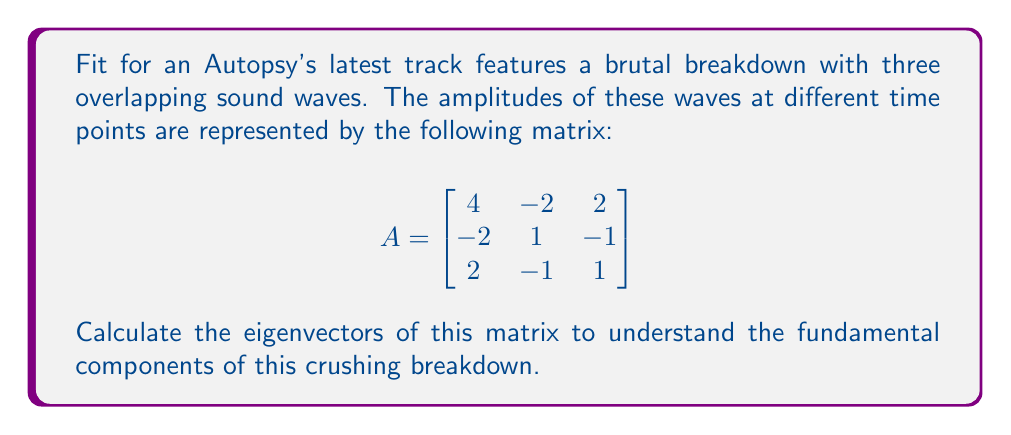Help me with this question. To find the eigenvectors, we follow these steps:

1) First, we need to find the eigenvalues by solving the characteristic equation:
   $$det(A - \lambda I) = 0$$

2) Expanding this:
   $$\begin{vmatrix}
   4-\lambda & -2 & 2 \\
   -2 & 1-\lambda & -1 \\
   2 & -1 & 1-\lambda
   \end{vmatrix} = 0$$

3) This gives us:
   $$(4-\lambda)((1-\lambda)^2 - 1) + 2(2(1-\lambda) + 2) - 2(-2(1-\lambda) - 1) = 0$$
   $$(4-\lambda)(1-2\lambda+\lambda^2 - 1) + 4(1-\lambda) + 4 + 4(1-\lambda) + 2 = 0$$
   $$-\lambda(4-\lambda)(\lambda-2) + 8-4\lambda + 4 + 4-4\lambda + 2 = 0$$
   $$-\lambda^3+2\lambda^2+4\lambda-8\lambda+14-8\lambda = 0$$
   $$-\lambda^3+2\lambda^2-12\lambda+14 = 0$$
   $$-(\lambda-2)(\lambda^2-14) = 0$$

4) Solving this, we get eigenvalues: $\lambda_1 = 2$, $\lambda_2 = \sqrt{14}$, $\lambda_3 = -\sqrt{14}$

5) For each eigenvalue, we solve $(A - \lambda I)v = 0$ to find the corresponding eigenvector:

   For $\lambda_1 = 2$:
   $$\begin{bmatrix}
   2 & -2 & 2 \\
   -2 & -1 & -1 \\
   2 & -1 & -1
   \end{bmatrix}\begin{bmatrix}
   x \\ y \\ z
   \end{bmatrix} = \begin{bmatrix}
   0 \\ 0 \\ 0
   \end{bmatrix}$$

   This gives us: $x = y = z$. We can choose $v_1 = (1, 1, 1)$.

   For $\lambda_2 = \sqrt{14}$ and $\lambda_3 = -\sqrt{14}$:
   $$\begin{bmatrix}
   4-\sqrt{14} & -2 & 2 \\
   -2 & 1-\sqrt{14} & -1 \\
   2 & -1 & 1-\sqrt{14}
   \end{bmatrix}\begin{bmatrix}
   x \\ y \\ z
   \end{bmatrix} = \begin{bmatrix}
   0 \\ 0 \\ 0
   \end{bmatrix}$$

   This gives us: $x = -\frac{\sqrt{14}-2}{2}y$, $z = y$. We can choose $v_2 = (-\frac{\sqrt{14}-2}{2}, 1, 1)$.

   Similarly, for $\lambda_3 = -\sqrt{14}$, we get $v_3 = (-\frac{-\sqrt{14}-2}{2}, 1, 1)$.
Answer: $v_1 = (1, 1, 1)$, $v_2 = (-\frac{\sqrt{14}-2}{2}, 1, 1)$, $v_3 = (-\frac{-\sqrt{14}-2}{2}, 1, 1)$ 